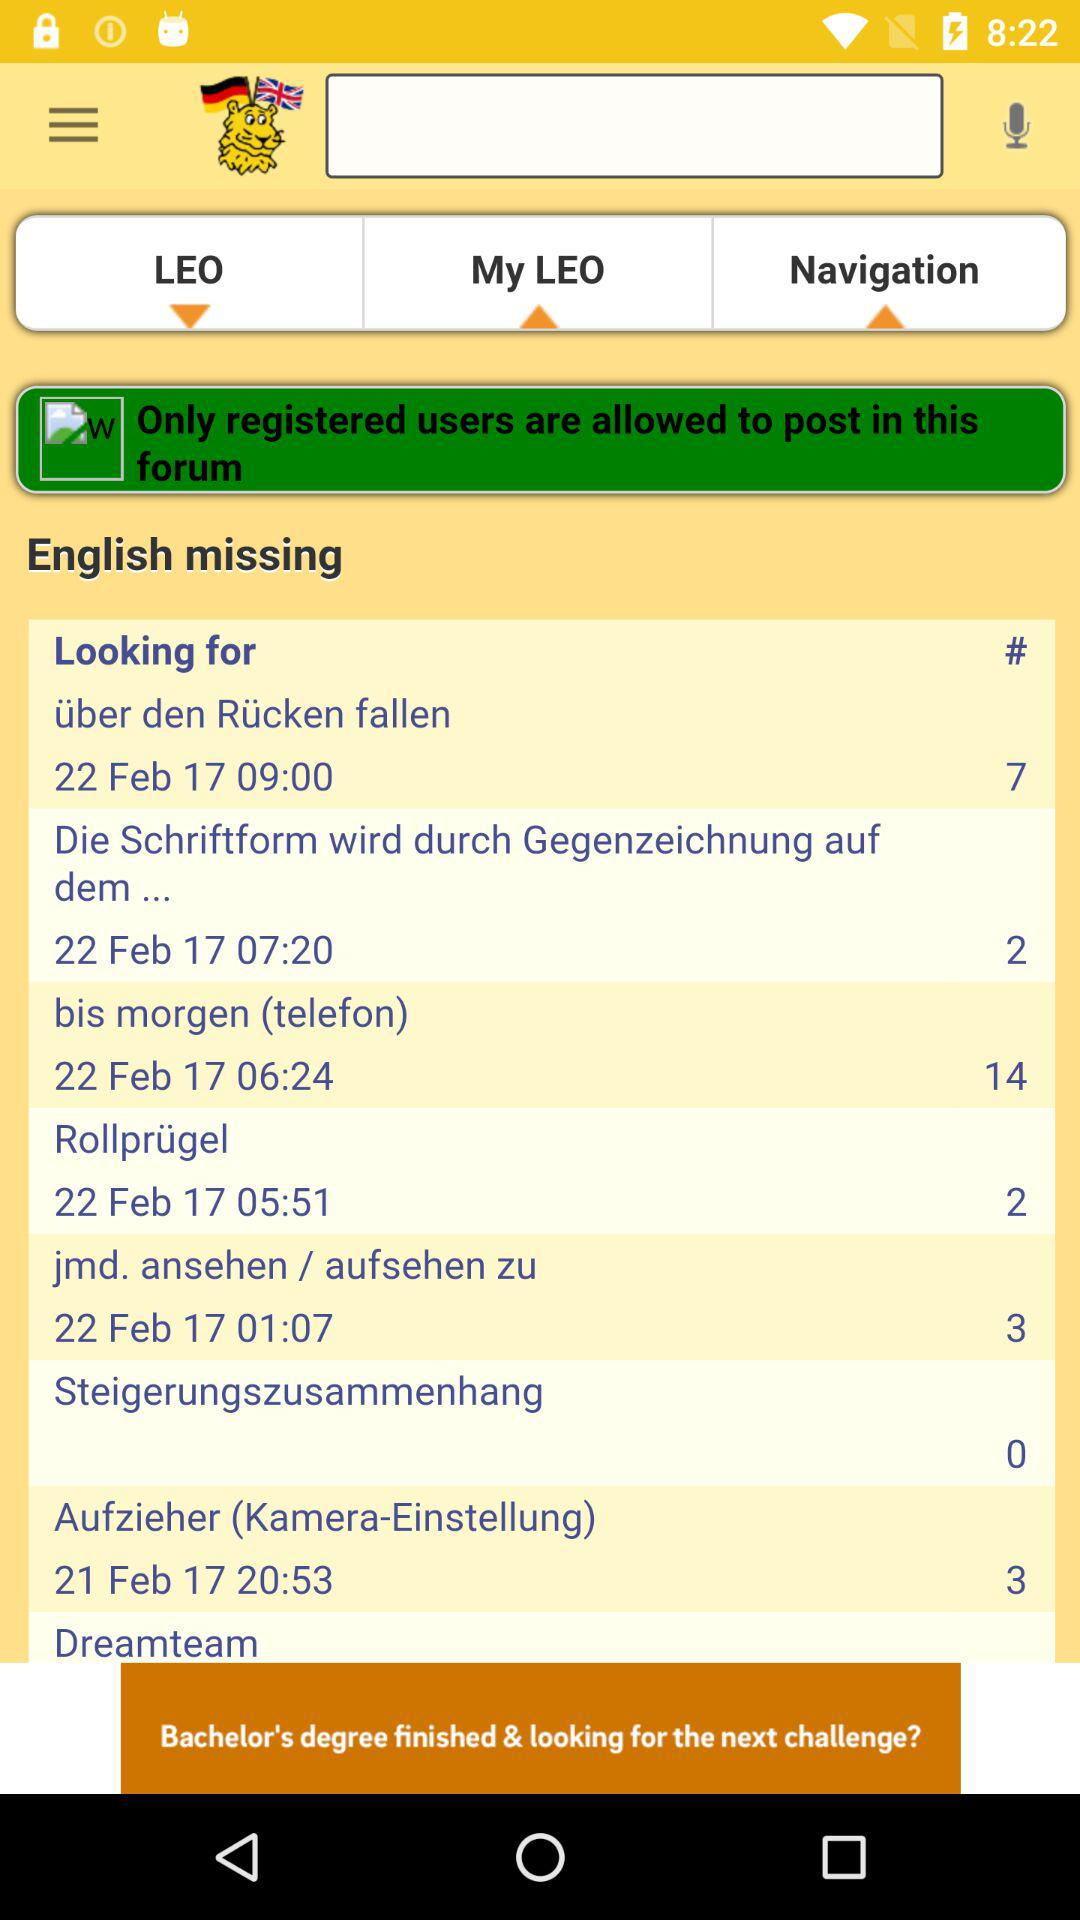What is the given date and time for Aufzieher? The given date and time are February 21, 2017 and 8:53 PM. 